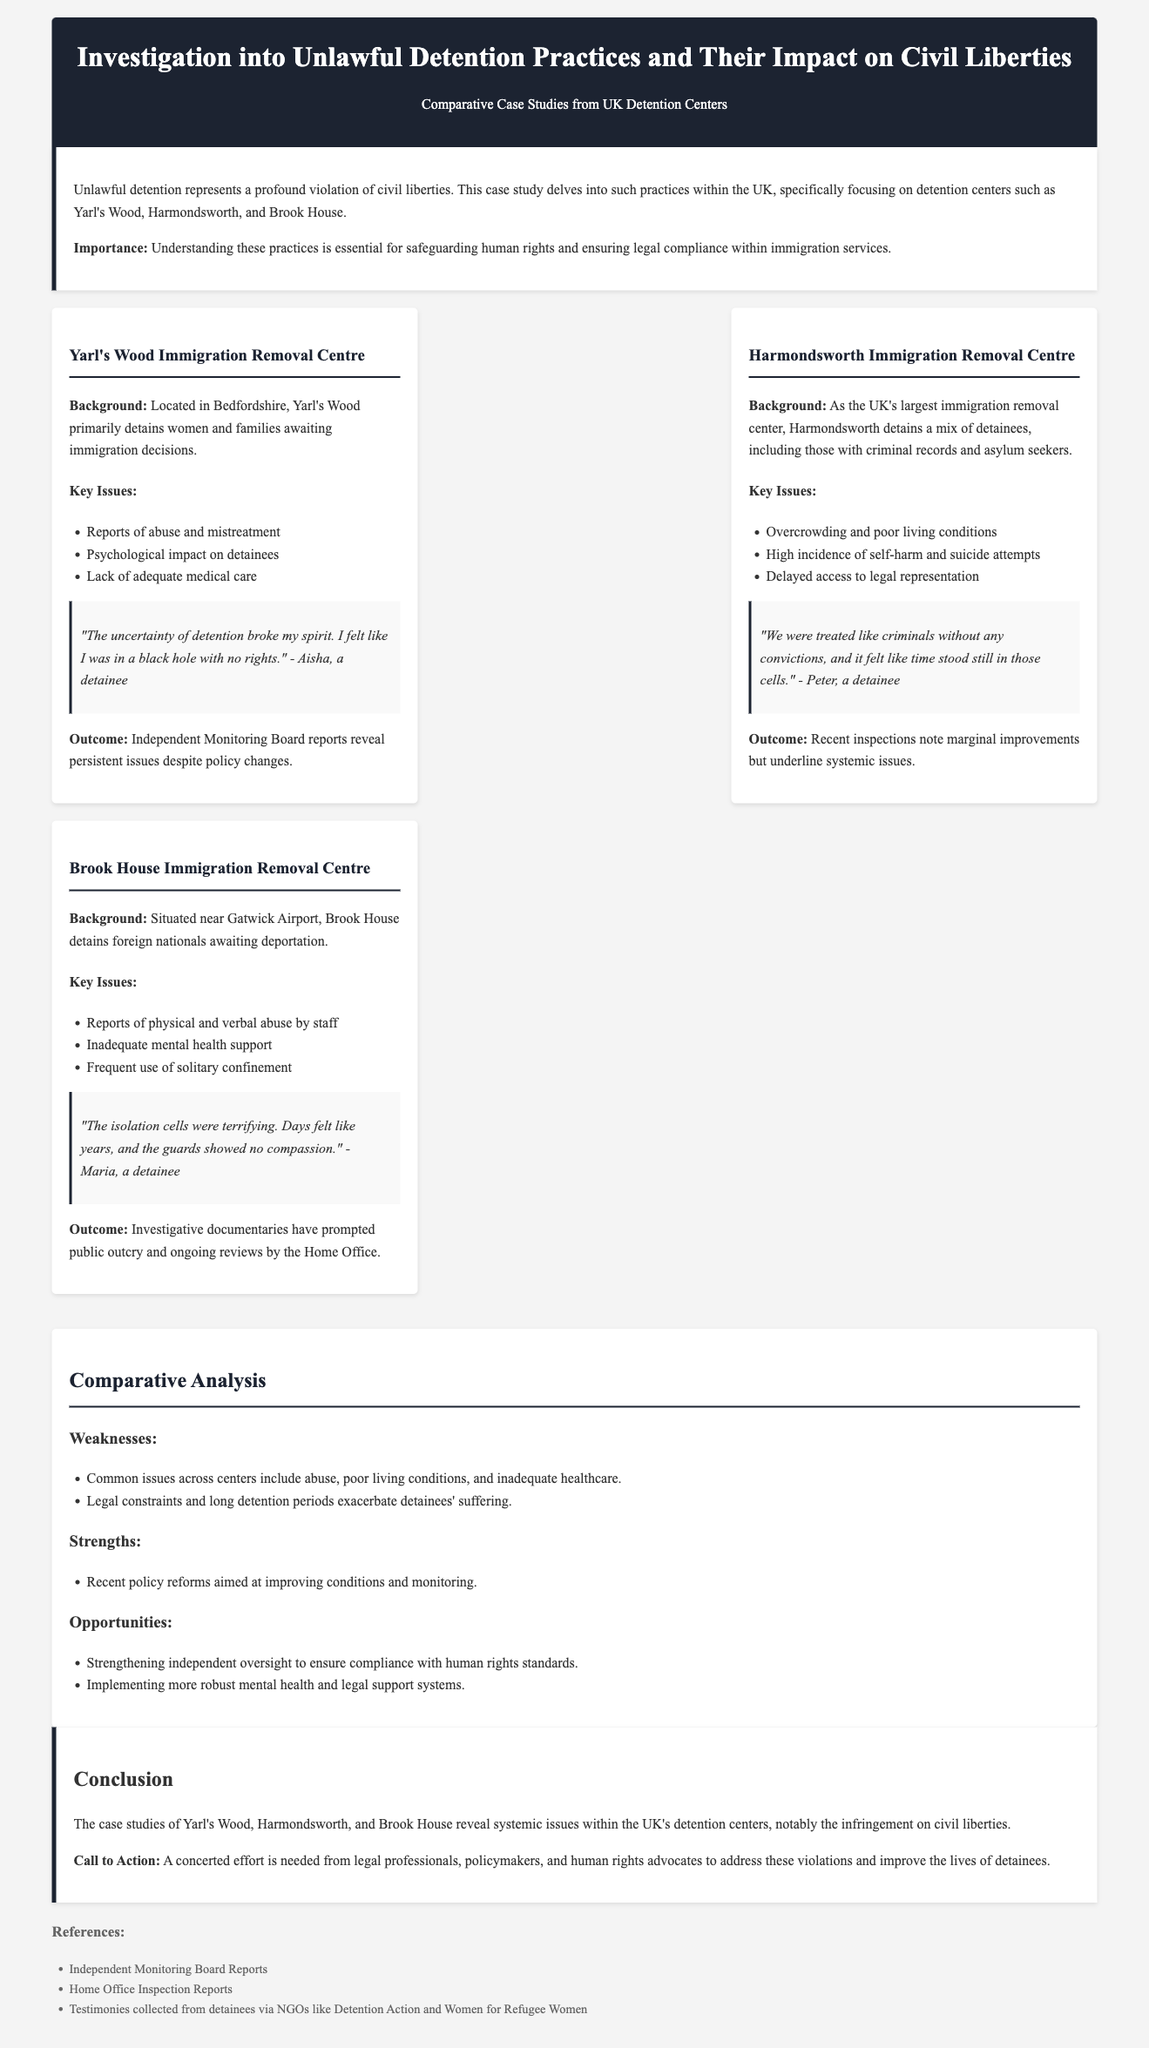What is the primary focus of the case study? The primary focus of the case study is on unlawful detention practices within UK detention centers, specifically their impact on civil liberties.
Answer: Unlawful detention practices Which center primarily detains women and families? Yarl's Wood Immigration Removal Centre primarily detains women and families awaiting immigration decisions.
Answer: Yarl's Wood What key issue is common across the detention centers analyzed? Common issues across the centers include abuse, poor living conditions, and inadequate healthcare.
Answer: Abuse, poor living conditions, and inadequate healthcare Who provided testimony regarding the psychological impact of detention at Yarl's Wood? Testimony regarding the psychological impact of detention at Yarl's Wood was provided by Aisha, a detainee.
Answer: Aisha What outcome was noted at Harmondsworth Immigration Removal Centre? Recent inspections note marginal improvements but underline systemic issues at Harmondsworth.
Answer: Marginal improvements but underline systemic issues Which organization collected testimonies from detainees? Testimonies were collected from detainees via NGOs like Detention Action and Women for Refugee Women.
Answer: Detention Action and Women for Refugee Women What is the location of Brook House Immigration Removal Centre? Brook House Immigration Removal Centre is situated near Gatwick Airport.
Answer: Near Gatwick Airport What call to action is made in the conclusion? The call to action emphasizes the need for legal professionals, policymakers, and human rights advocates to address violations.
Answer: Address violations What does the section on weaknesses highlight? The weaknesses section highlights that common issues include abuse, poor living conditions, and inadequate healthcare.
Answer: Abuse, poor living conditions, and inadequate healthcare 